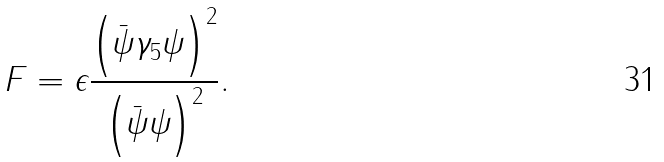<formula> <loc_0><loc_0><loc_500><loc_500>F = \epsilon \frac { \left ( \bar { \psi } \gamma _ { 5 } \psi \right ) ^ { 2 } } { \left ( \bar { \psi } \psi \right ) ^ { 2 } } .</formula> 